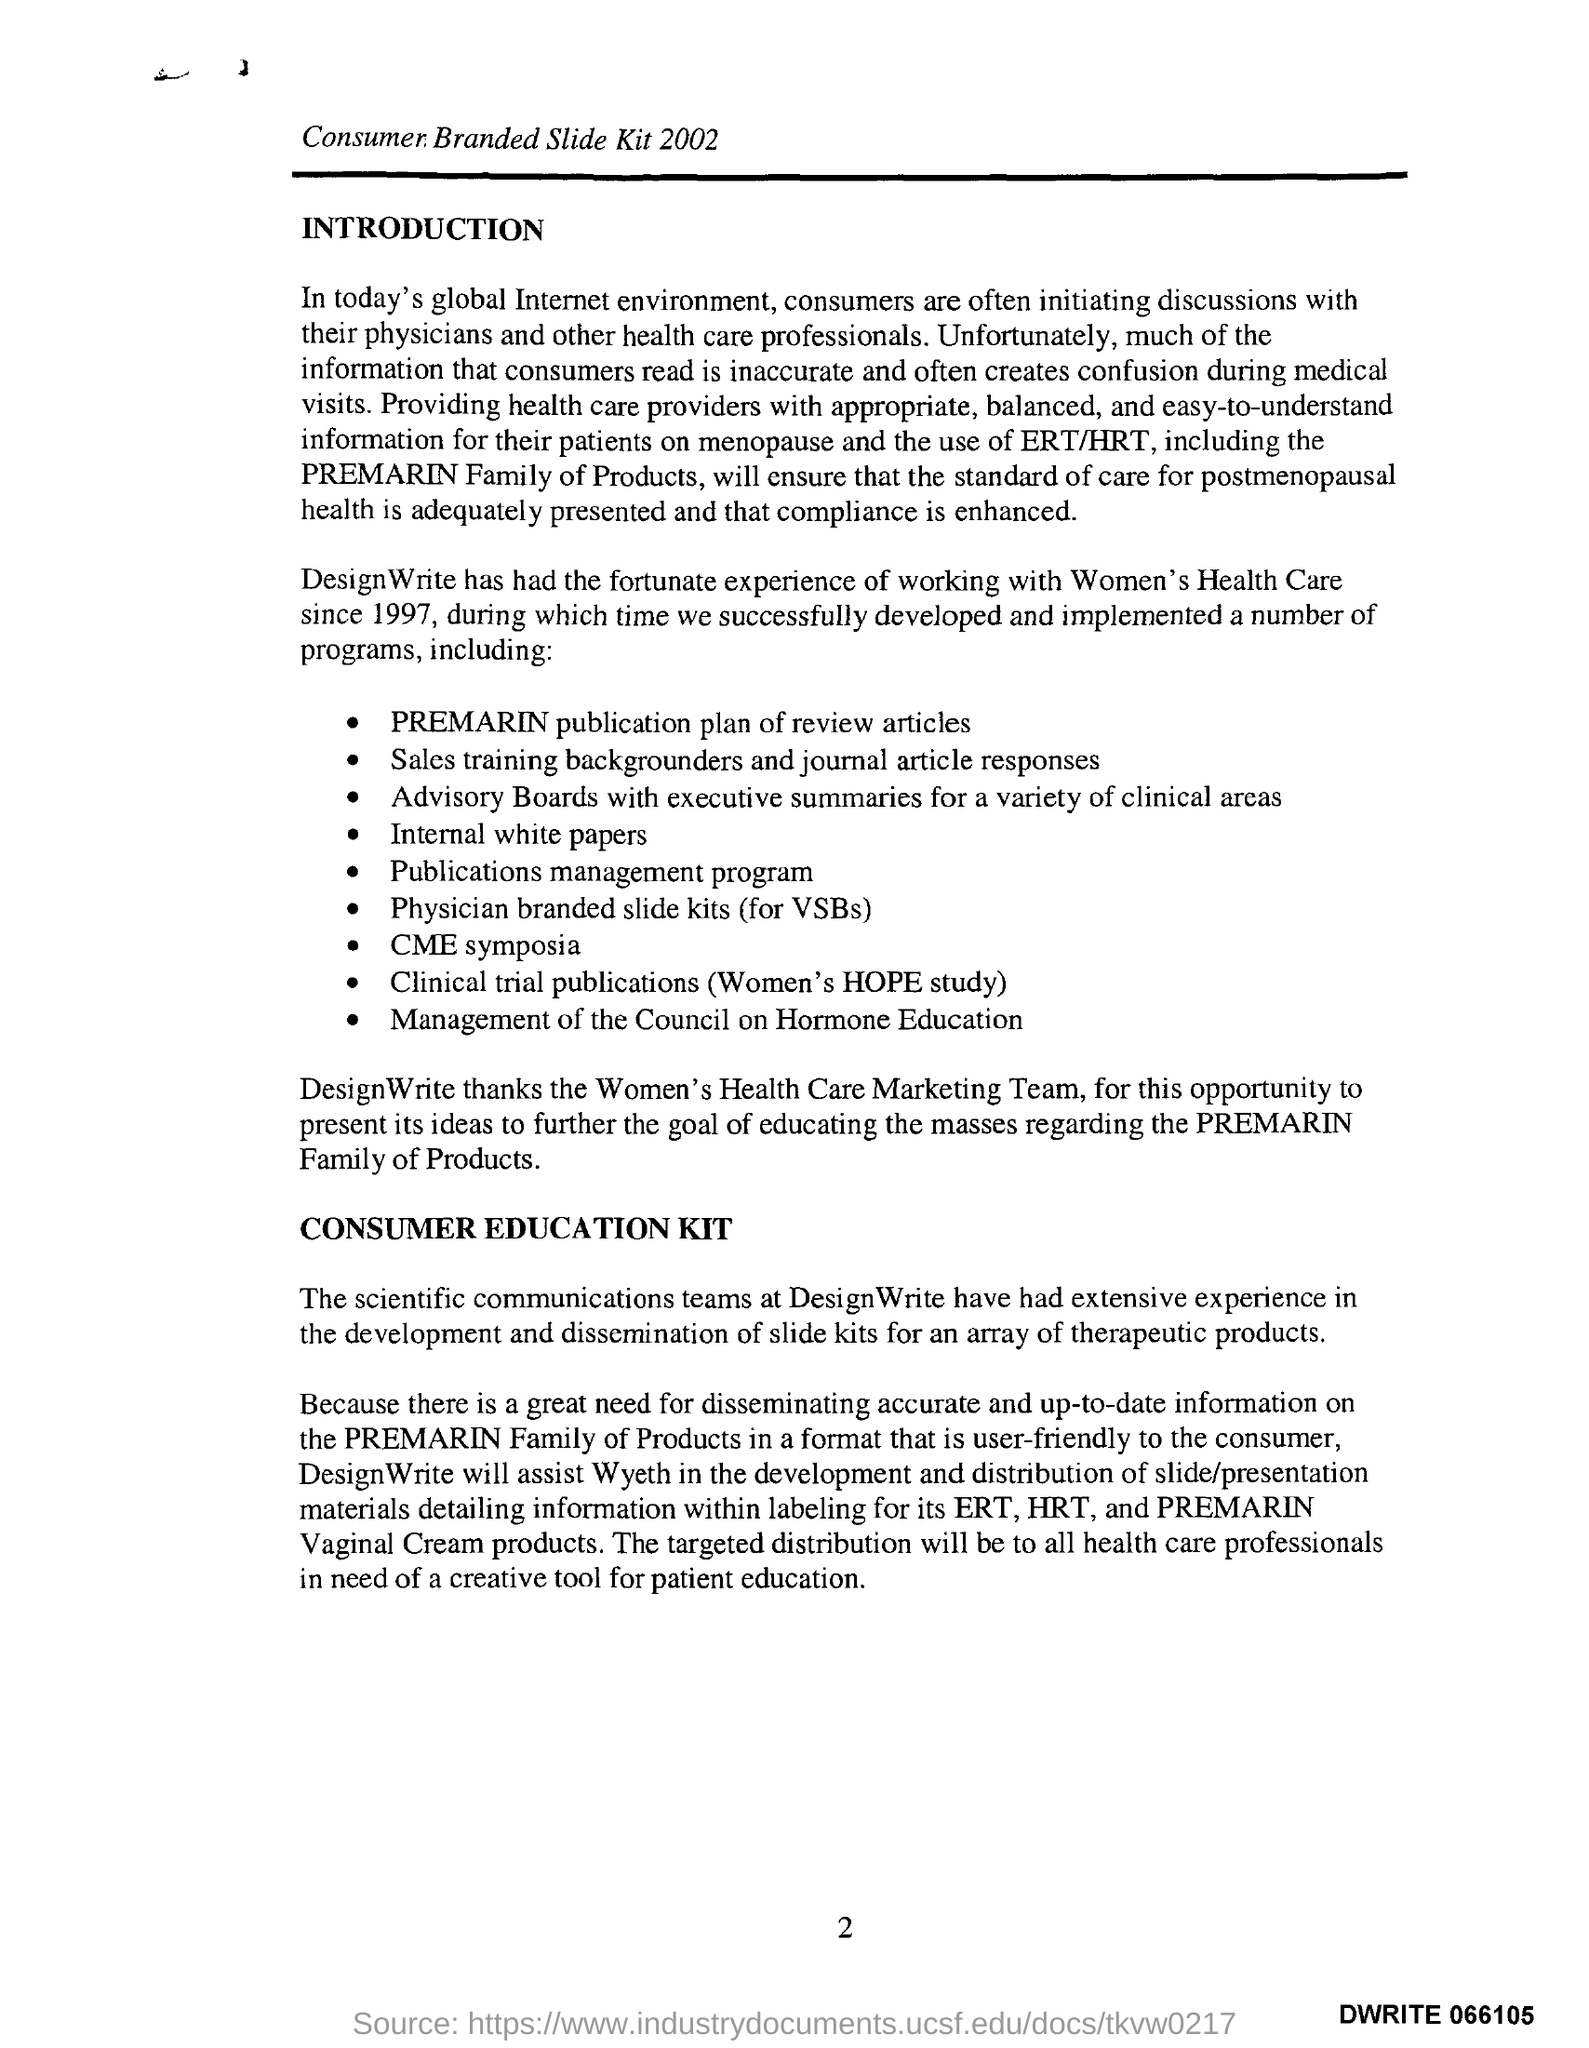What is the Page Number?
Your response must be concise. 2. What is the first title below the line?
Ensure brevity in your answer.  INTRODUCTION. What is the second title below the line?
Your answer should be very brief. CONSUMER EDUCATION KIT. What is the title above the line?
Provide a short and direct response. Consumer Branded slide Kit 2002. 